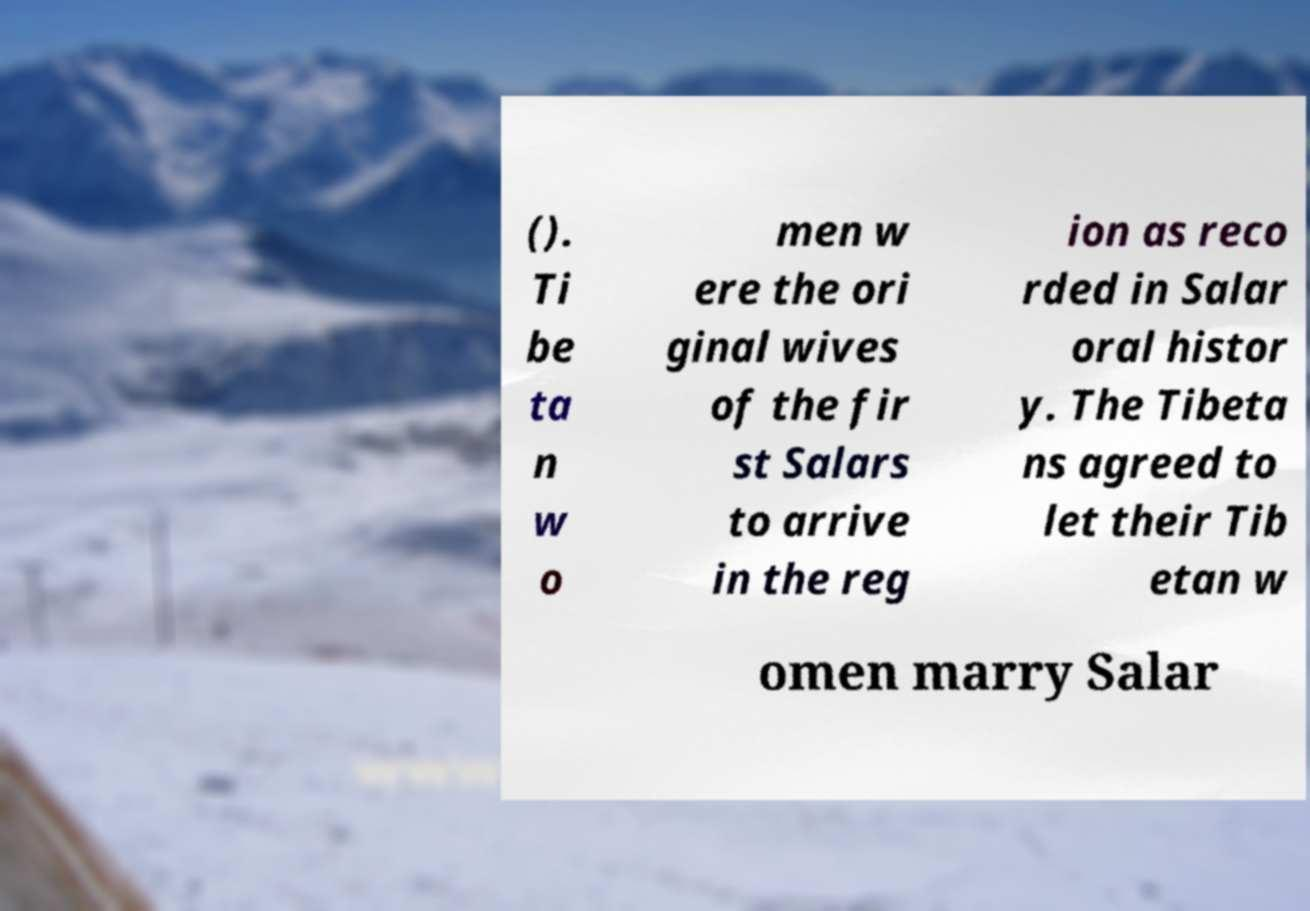For documentation purposes, I need the text within this image transcribed. Could you provide that? (). Ti be ta n w o men w ere the ori ginal wives of the fir st Salars to arrive in the reg ion as reco rded in Salar oral histor y. The Tibeta ns agreed to let their Tib etan w omen marry Salar 